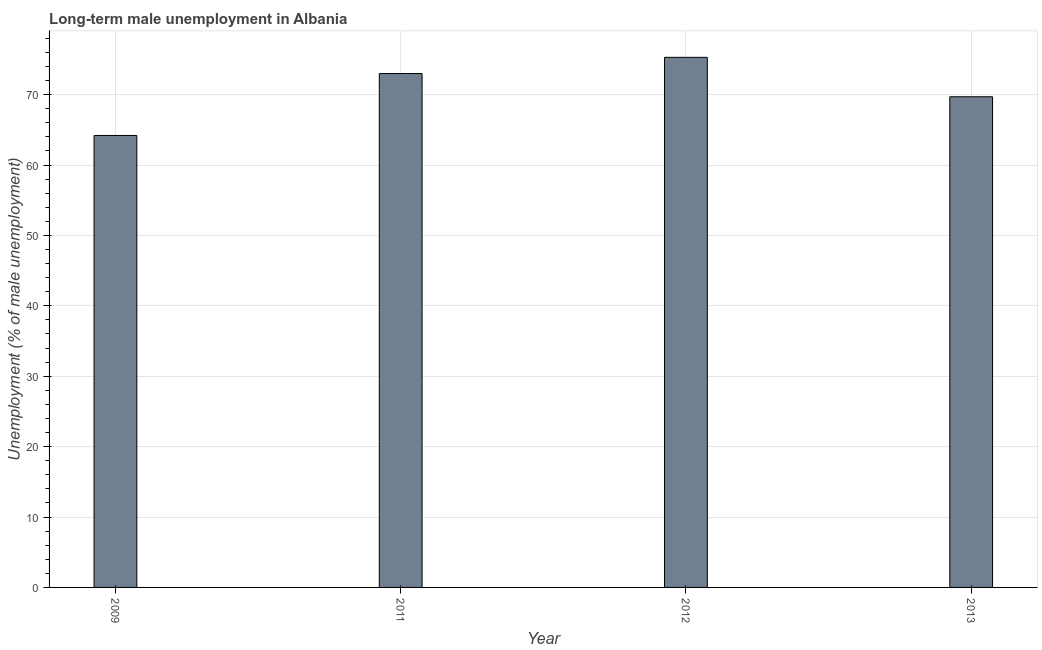What is the title of the graph?
Provide a short and direct response. Long-term male unemployment in Albania. What is the label or title of the Y-axis?
Give a very brief answer. Unemployment (% of male unemployment). What is the long-term male unemployment in 2012?
Your response must be concise. 75.3. Across all years, what is the maximum long-term male unemployment?
Provide a succinct answer. 75.3. Across all years, what is the minimum long-term male unemployment?
Your answer should be very brief. 64.2. In which year was the long-term male unemployment minimum?
Offer a very short reply. 2009. What is the sum of the long-term male unemployment?
Keep it short and to the point. 282.2. What is the difference between the long-term male unemployment in 2011 and 2013?
Provide a short and direct response. 3.3. What is the average long-term male unemployment per year?
Keep it short and to the point. 70.55. What is the median long-term male unemployment?
Make the answer very short. 71.35. Do a majority of the years between 2009 and 2011 (inclusive) have long-term male unemployment greater than 64 %?
Provide a succinct answer. Yes. What is the ratio of the long-term male unemployment in 2012 to that in 2013?
Your answer should be compact. 1.08. Is the long-term male unemployment in 2009 less than that in 2012?
Provide a short and direct response. Yes. Is the sum of the long-term male unemployment in 2009 and 2012 greater than the maximum long-term male unemployment across all years?
Your response must be concise. Yes. What is the difference between the highest and the lowest long-term male unemployment?
Provide a succinct answer. 11.1. In how many years, is the long-term male unemployment greater than the average long-term male unemployment taken over all years?
Provide a succinct answer. 2. How many bars are there?
Keep it short and to the point. 4. Are all the bars in the graph horizontal?
Keep it short and to the point. No. How many years are there in the graph?
Provide a short and direct response. 4. What is the difference between two consecutive major ticks on the Y-axis?
Give a very brief answer. 10. What is the Unemployment (% of male unemployment) of 2009?
Keep it short and to the point. 64.2. What is the Unemployment (% of male unemployment) of 2011?
Offer a terse response. 73. What is the Unemployment (% of male unemployment) of 2012?
Keep it short and to the point. 75.3. What is the Unemployment (% of male unemployment) of 2013?
Provide a succinct answer. 69.7. What is the difference between the Unemployment (% of male unemployment) in 2009 and 2011?
Provide a succinct answer. -8.8. What is the difference between the Unemployment (% of male unemployment) in 2009 and 2012?
Offer a terse response. -11.1. What is the difference between the Unemployment (% of male unemployment) in 2009 and 2013?
Offer a terse response. -5.5. What is the difference between the Unemployment (% of male unemployment) in 2011 and 2012?
Your response must be concise. -2.3. What is the difference between the Unemployment (% of male unemployment) in 2011 and 2013?
Give a very brief answer. 3.3. What is the difference between the Unemployment (% of male unemployment) in 2012 and 2013?
Make the answer very short. 5.6. What is the ratio of the Unemployment (% of male unemployment) in 2009 to that in 2011?
Ensure brevity in your answer.  0.88. What is the ratio of the Unemployment (% of male unemployment) in 2009 to that in 2012?
Ensure brevity in your answer.  0.85. What is the ratio of the Unemployment (% of male unemployment) in 2009 to that in 2013?
Your response must be concise. 0.92. What is the ratio of the Unemployment (% of male unemployment) in 2011 to that in 2013?
Make the answer very short. 1.05. What is the ratio of the Unemployment (% of male unemployment) in 2012 to that in 2013?
Keep it short and to the point. 1.08. 